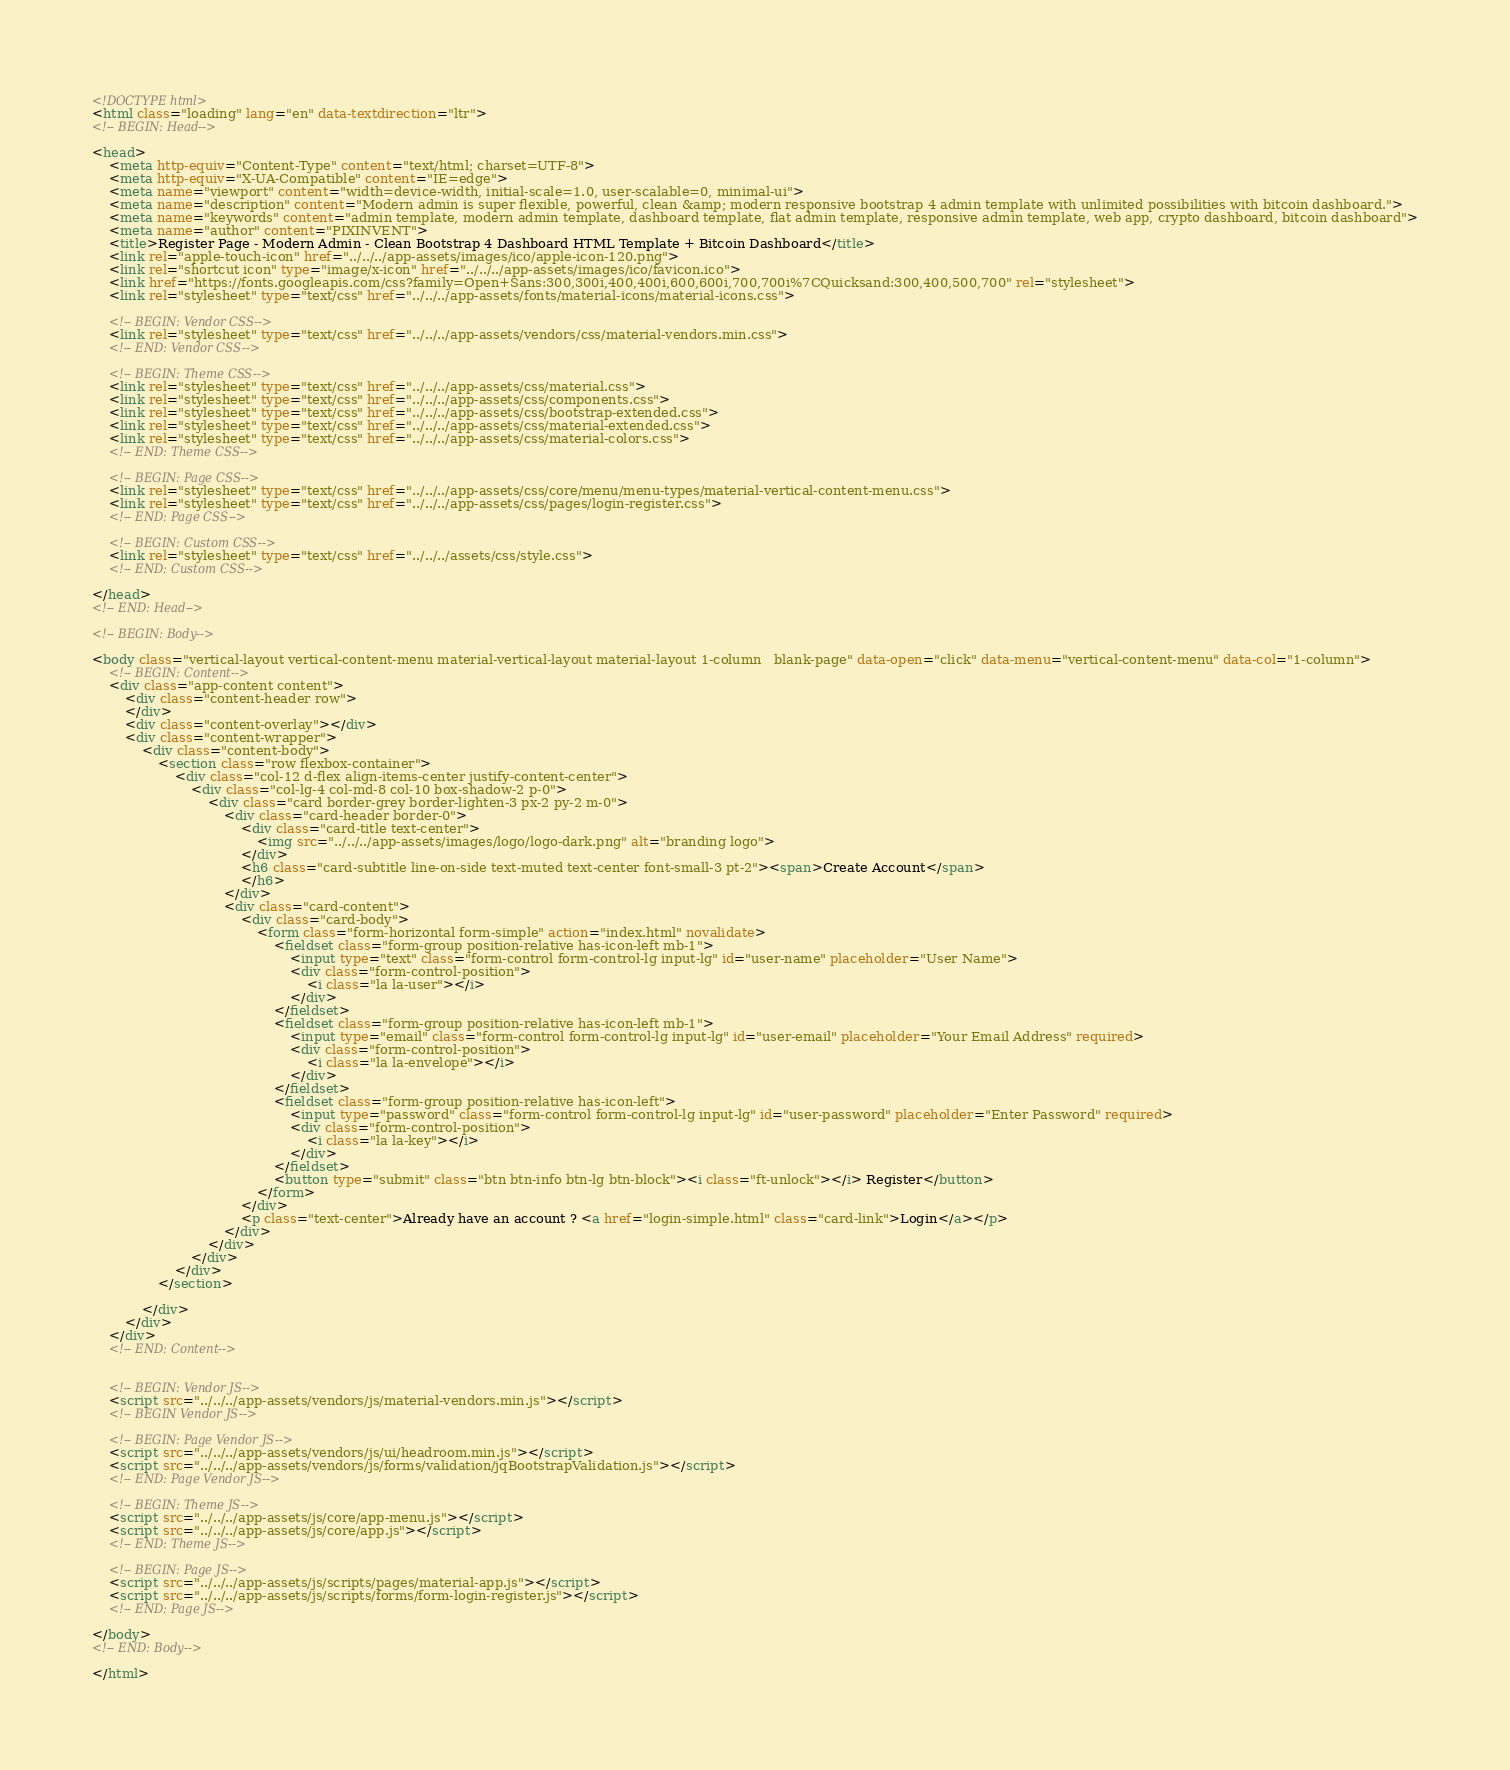<code> <loc_0><loc_0><loc_500><loc_500><_HTML_><!DOCTYPE html>
<html class="loading" lang="en" data-textdirection="ltr">
<!-- BEGIN: Head-->

<head>
    <meta http-equiv="Content-Type" content="text/html; charset=UTF-8">
    <meta http-equiv="X-UA-Compatible" content="IE=edge">
    <meta name="viewport" content="width=device-width, initial-scale=1.0, user-scalable=0, minimal-ui">
    <meta name="description" content="Modern admin is super flexible, powerful, clean &amp; modern responsive bootstrap 4 admin template with unlimited possibilities with bitcoin dashboard.">
    <meta name="keywords" content="admin template, modern admin template, dashboard template, flat admin template, responsive admin template, web app, crypto dashboard, bitcoin dashboard">
    <meta name="author" content="PIXINVENT">
    <title>Register Page - Modern Admin - Clean Bootstrap 4 Dashboard HTML Template + Bitcoin Dashboard</title>
    <link rel="apple-touch-icon" href="../../../app-assets/images/ico/apple-icon-120.png">
    <link rel="shortcut icon" type="image/x-icon" href="../../../app-assets/images/ico/favicon.ico">
    <link href="https://fonts.googleapis.com/css?family=Open+Sans:300,300i,400,400i,600,600i,700,700i%7CQuicksand:300,400,500,700" rel="stylesheet">
    <link rel="stylesheet" type="text/css" href="../../../app-assets/fonts/material-icons/material-icons.css">

    <!-- BEGIN: Vendor CSS-->
    <link rel="stylesheet" type="text/css" href="../../../app-assets/vendors/css/material-vendors.min.css">
    <!-- END: Vendor CSS-->

    <!-- BEGIN: Theme CSS-->
    <link rel="stylesheet" type="text/css" href="../../../app-assets/css/material.css">
    <link rel="stylesheet" type="text/css" href="../../../app-assets/css/components.css">
    <link rel="stylesheet" type="text/css" href="../../../app-assets/css/bootstrap-extended.css">
    <link rel="stylesheet" type="text/css" href="../../../app-assets/css/material-extended.css">
    <link rel="stylesheet" type="text/css" href="../../../app-assets/css/material-colors.css">
    <!-- END: Theme CSS-->

    <!-- BEGIN: Page CSS-->
    <link rel="stylesheet" type="text/css" href="../../../app-assets/css/core/menu/menu-types/material-vertical-content-menu.css">
    <link rel="stylesheet" type="text/css" href="../../../app-assets/css/pages/login-register.css">
    <!-- END: Page CSS-->

    <!-- BEGIN: Custom CSS-->
    <link rel="stylesheet" type="text/css" href="../../../assets/css/style.css">
    <!-- END: Custom CSS-->

</head>
<!-- END: Head-->

<!-- BEGIN: Body-->

<body class="vertical-layout vertical-content-menu material-vertical-layout material-layout 1-column   blank-page" data-open="click" data-menu="vertical-content-menu" data-col="1-column">
    <!-- BEGIN: Content-->
    <div class="app-content content">
        <div class="content-header row">
        </div>
        <div class="content-overlay"></div>
        <div class="content-wrapper">
            <div class="content-body">
                <section class="row flexbox-container">
                    <div class="col-12 d-flex align-items-center justify-content-center">
                        <div class="col-lg-4 col-md-8 col-10 box-shadow-2 p-0">
                            <div class="card border-grey border-lighten-3 px-2 py-2 m-0">
                                <div class="card-header border-0">
                                    <div class="card-title text-center">
                                        <img src="../../../app-assets/images/logo/logo-dark.png" alt="branding logo">
                                    </div>
                                    <h6 class="card-subtitle line-on-side text-muted text-center font-small-3 pt-2"><span>Create Account</span>
                                    </h6>
                                </div>
                                <div class="card-content">
                                    <div class="card-body">
                                        <form class="form-horizontal form-simple" action="index.html" novalidate>
                                            <fieldset class="form-group position-relative has-icon-left mb-1">
                                                <input type="text" class="form-control form-control-lg input-lg" id="user-name" placeholder="User Name">
                                                <div class="form-control-position">
                                                    <i class="la la-user"></i>
                                                </div>
                                            </fieldset>
                                            <fieldset class="form-group position-relative has-icon-left mb-1">
                                                <input type="email" class="form-control form-control-lg input-lg" id="user-email" placeholder="Your Email Address" required>
                                                <div class="form-control-position">
                                                    <i class="la la-envelope"></i>
                                                </div>
                                            </fieldset>
                                            <fieldset class="form-group position-relative has-icon-left">
                                                <input type="password" class="form-control form-control-lg input-lg" id="user-password" placeholder="Enter Password" required>
                                                <div class="form-control-position">
                                                    <i class="la la-key"></i>
                                                </div>
                                            </fieldset>
                                            <button type="submit" class="btn btn-info btn-lg btn-block"><i class="ft-unlock"></i> Register</button>
                                        </form>
                                    </div>
                                    <p class="text-center">Already have an account ? <a href="login-simple.html" class="card-link">Login</a></p>
                                </div>
                            </div>
                        </div>
                    </div>
                </section>

            </div>
        </div>
    </div>
    <!-- END: Content-->


    <!-- BEGIN: Vendor JS-->
    <script src="../../../app-assets/vendors/js/material-vendors.min.js"></script>
    <!-- BEGIN Vendor JS-->

    <!-- BEGIN: Page Vendor JS-->
    <script src="../../../app-assets/vendors/js/ui/headroom.min.js"></script>
    <script src="../../../app-assets/vendors/js/forms/validation/jqBootstrapValidation.js"></script>
    <!-- END: Page Vendor JS-->

    <!-- BEGIN: Theme JS-->
    <script src="../../../app-assets/js/core/app-menu.js"></script>
    <script src="../../../app-assets/js/core/app.js"></script>
    <!-- END: Theme JS-->

    <!-- BEGIN: Page JS-->
    <script src="../../../app-assets/js/scripts/pages/material-app.js"></script>
    <script src="../../../app-assets/js/scripts/forms/form-login-register.js"></script>
    <!-- END: Page JS-->

</body>
<!-- END: Body-->

</html></code> 